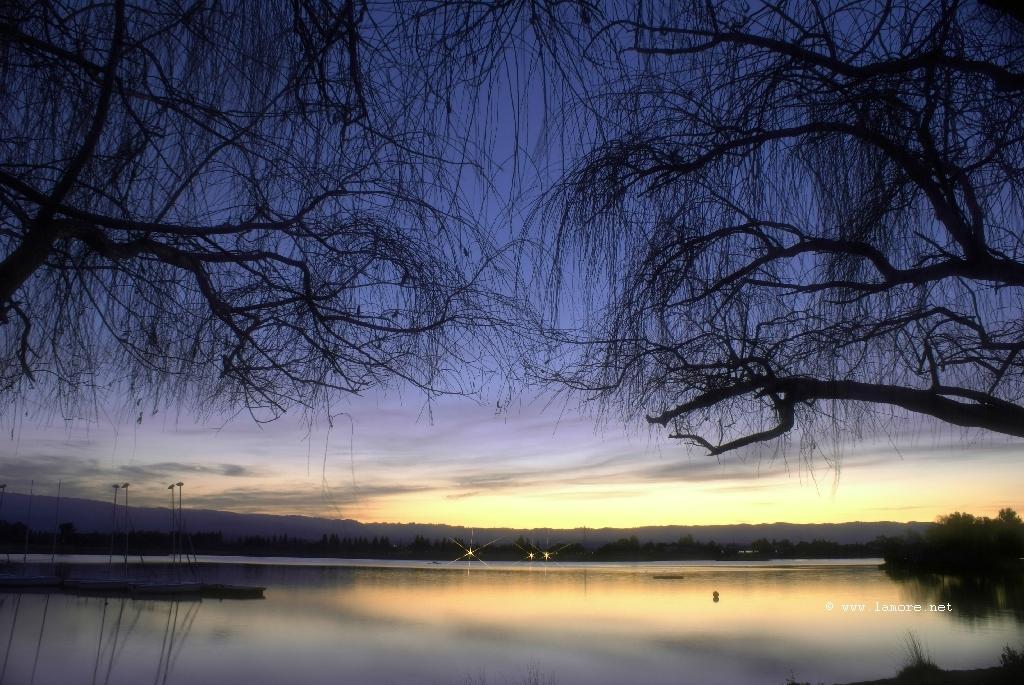Please provide a concise description of this image. As we can see in the image there is water and trees. In the background there are lights. On the top there is sky. 